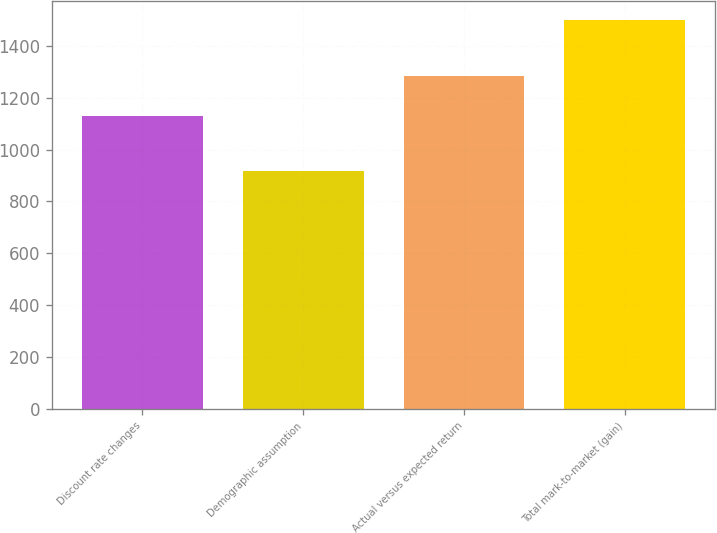Convert chart. <chart><loc_0><loc_0><loc_500><loc_500><bar_chart><fcel>Discount rate changes<fcel>Demographic assumption<fcel>Actual versus expected return<fcel>Total mark-to-market (gain)<nl><fcel>1129<fcel>916<fcel>1285<fcel>1498<nl></chart> 